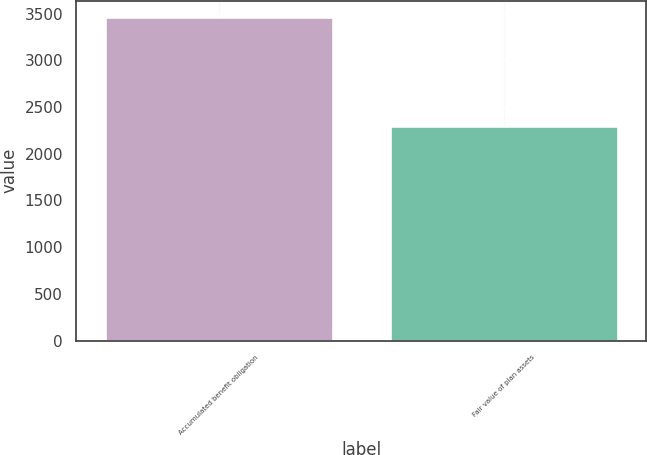Convert chart. <chart><loc_0><loc_0><loc_500><loc_500><bar_chart><fcel>Accumulated benefit obligation<fcel>Fair value of plan assets<nl><fcel>3468<fcel>2300<nl></chart> 